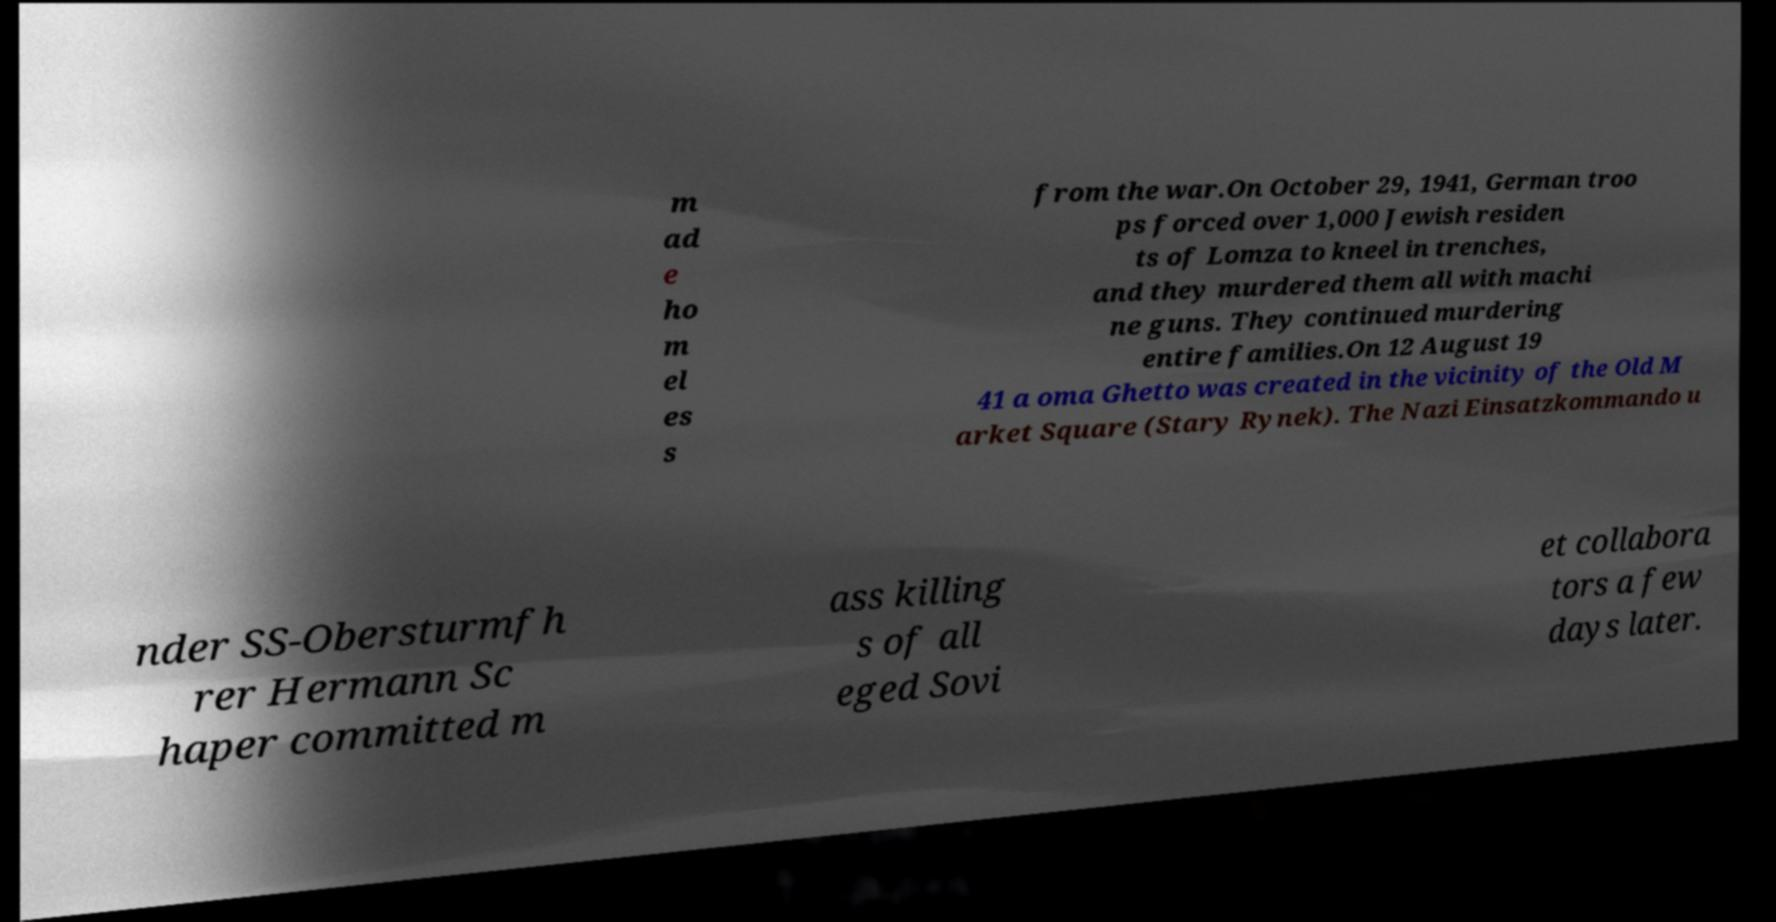For documentation purposes, I need the text within this image transcribed. Could you provide that? m ad e ho m el es s from the war.On October 29, 1941, German troo ps forced over 1,000 Jewish residen ts of Lomza to kneel in trenches, and they murdered them all with machi ne guns. They continued murdering entire families.On 12 August 19 41 a oma Ghetto was created in the vicinity of the Old M arket Square (Stary Rynek). The Nazi Einsatzkommando u nder SS-Obersturmfh rer Hermann Sc haper committed m ass killing s of all eged Sovi et collabora tors a few days later. 